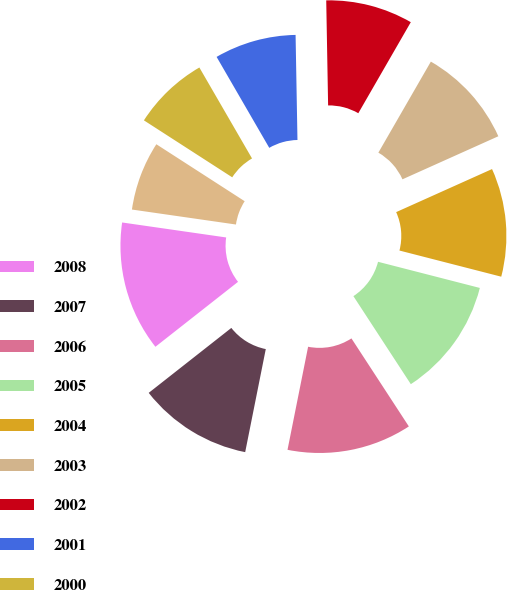<chart> <loc_0><loc_0><loc_500><loc_500><pie_chart><fcel>2008<fcel>2007<fcel>2006<fcel>2005<fcel>2004<fcel>2003<fcel>2002<fcel>2001<fcel>2000<fcel>1999<nl><fcel>12.88%<fcel>11.26%<fcel>12.34%<fcel>11.8%<fcel>10.72%<fcel>9.96%<fcel>8.61%<fcel>8.07%<fcel>7.53%<fcel>6.84%<nl></chart> 